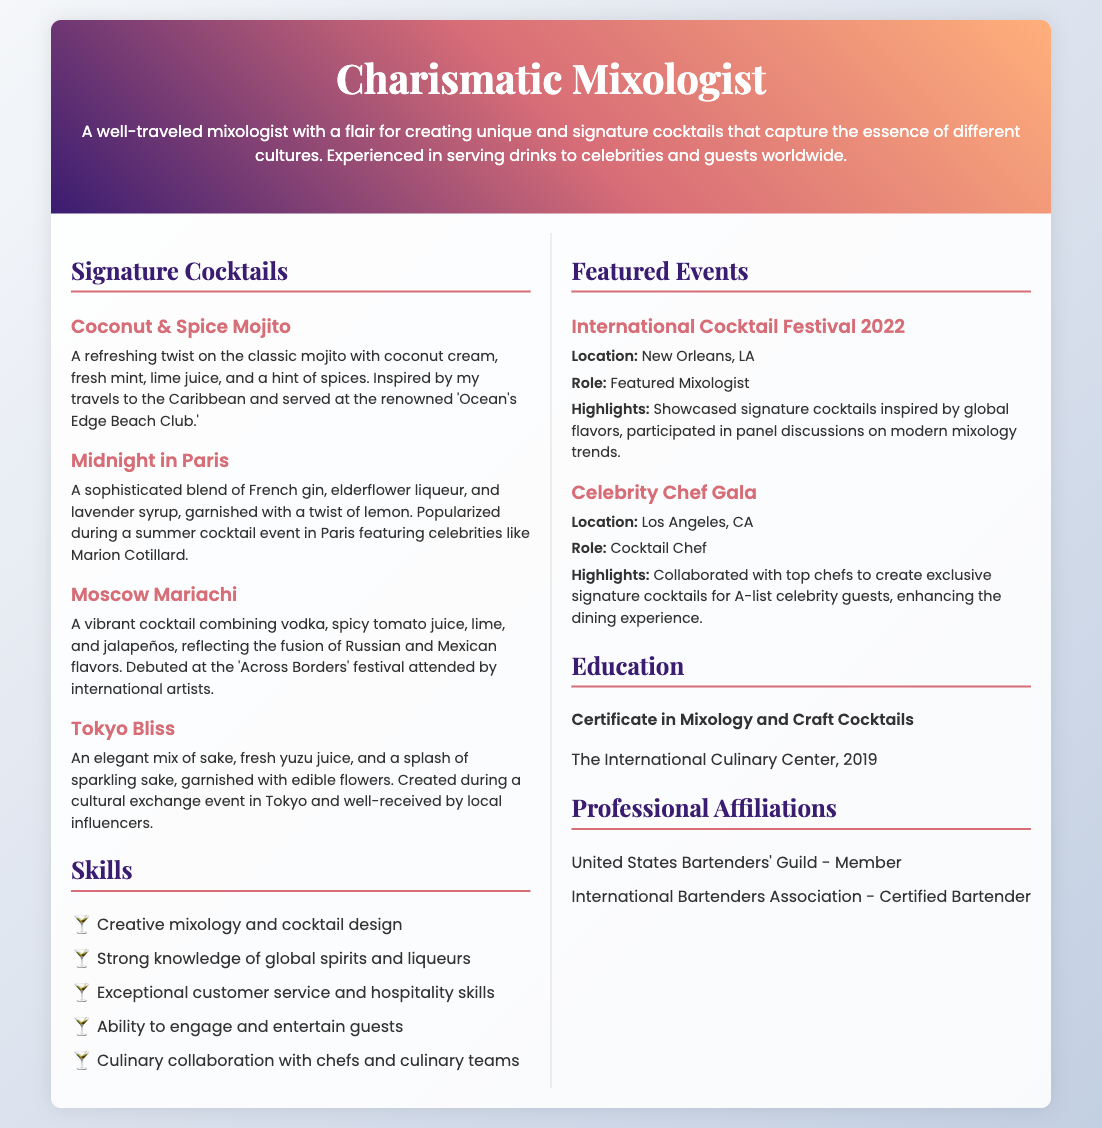what is the name of the first signature cocktail? The first signature cocktail listed in the document is "Coconut & Spice Mojito."
Answer: Coconut & Spice Mojito where was the International Cocktail Festival 2022 held? The location of the International Cocktail Festival 2022 is specified in the document as New Orleans, LA.
Answer: New Orleans, LA who is a notable celebrity mentioned in connection with the "Midnight in Paris" cocktail? The document mentions Marion Cotillard as a notable celebrity related to the "Midnight in Paris" cocktail.
Answer: Marion Cotillard how many signature cocktails are listed in the Resume? The document lists a total of four signature cocktails.
Answer: four what type of event was the "Celebrity Chef Gala"? The "Celebrity Chef Gala" is referred to as a gala event in the document.
Answer: gala which organization is the mixologist a member of? The mixologist is a member of the United States Bartenders' Guild.
Answer: United States Bartenders' Guild what year did the mixologist receive their certificate in mixology? The document states that the mixologist received their certificate in mixology in 2019.
Answer: 2019 what is the name of the cocktail that reflects Russian and Mexican flavors? The cocktail that reflects Russian and Mexican flavors is called "Moscow Mariachi."
Answer: Moscow Mariachi what role did the mixologist have at the Celebrity Chef Gala? The document describes the mixologist's role at the Celebrity Chef Gala as Cocktail Chef.
Answer: Cocktail Chef 